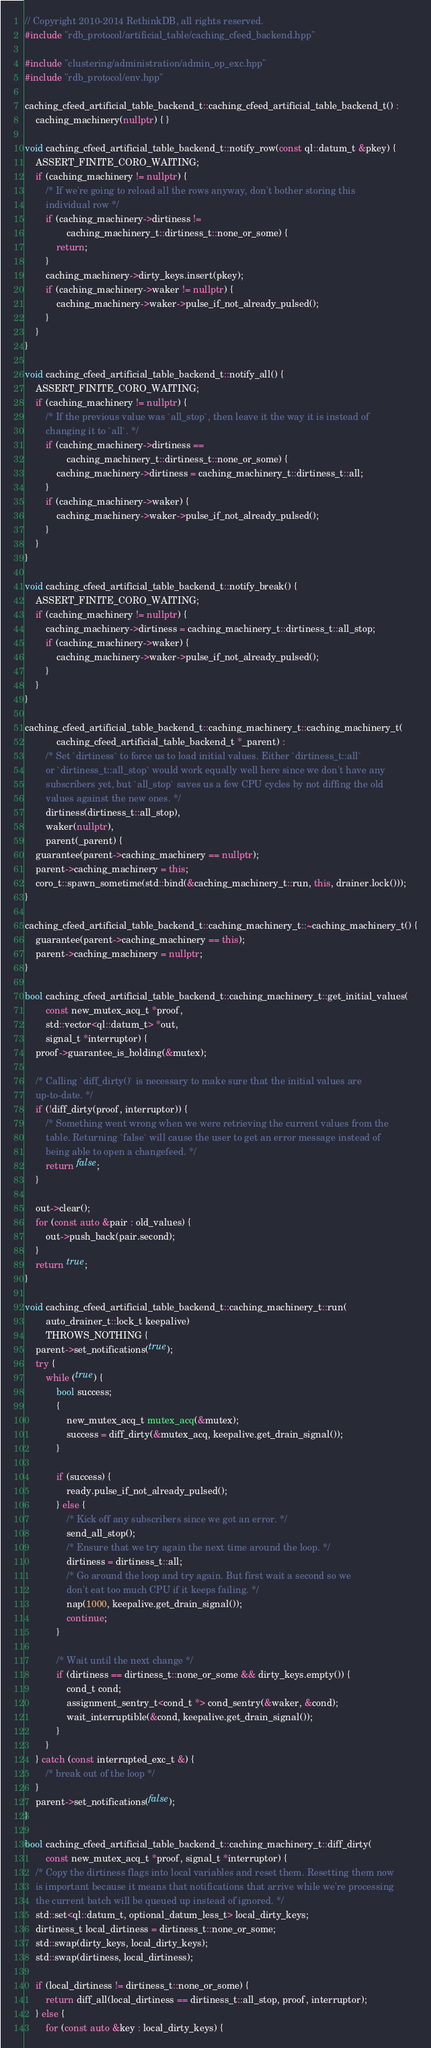<code> <loc_0><loc_0><loc_500><loc_500><_C++_>// Copyright 2010-2014 RethinkDB, all rights reserved.
#include "rdb_protocol/artificial_table/caching_cfeed_backend.hpp"

#include "clustering/administration/admin_op_exc.hpp"
#include "rdb_protocol/env.hpp"

caching_cfeed_artificial_table_backend_t::caching_cfeed_artificial_table_backend_t() :
    caching_machinery(nullptr) { }

void caching_cfeed_artificial_table_backend_t::notify_row(const ql::datum_t &pkey) {
    ASSERT_FINITE_CORO_WAITING;
    if (caching_machinery != nullptr) {
        /* If we're going to reload all the rows anyway, don't bother storing this
        individual row */
        if (caching_machinery->dirtiness !=
                caching_machinery_t::dirtiness_t::none_or_some) {
            return;
        }
        caching_machinery->dirty_keys.insert(pkey);
        if (caching_machinery->waker != nullptr) {
            caching_machinery->waker->pulse_if_not_already_pulsed();
        }
    }
}

void caching_cfeed_artificial_table_backend_t::notify_all() {
    ASSERT_FINITE_CORO_WAITING;
    if (caching_machinery != nullptr) {
        /* If the previous value was `all_stop`, then leave it the way it is instead of
        changing it to `all`. */
        if (caching_machinery->dirtiness ==
                caching_machinery_t::dirtiness_t::none_or_some) {
            caching_machinery->dirtiness = caching_machinery_t::dirtiness_t::all;
        }
        if (caching_machinery->waker) {
            caching_machinery->waker->pulse_if_not_already_pulsed();
        }
    }
}

void caching_cfeed_artificial_table_backend_t::notify_break() {
    ASSERT_FINITE_CORO_WAITING;
    if (caching_machinery != nullptr) {
        caching_machinery->dirtiness = caching_machinery_t::dirtiness_t::all_stop;
        if (caching_machinery->waker) {
            caching_machinery->waker->pulse_if_not_already_pulsed();
        }
    }
}

caching_cfeed_artificial_table_backend_t::caching_machinery_t::caching_machinery_t(
            caching_cfeed_artificial_table_backend_t *_parent) :
        /* Set `dirtiness` to force us to load initial values. Either `dirtiness_t::all`
        or `dirtiness_t::all_stop` would work equally well here since we don't have any
        subscribers yet, but `all_stop` saves us a few CPU cycles by not diffing the old
        values against the new ones. */
        dirtiness(dirtiness_t::all_stop),
        waker(nullptr),
        parent(_parent) {
    guarantee(parent->caching_machinery == nullptr);
    parent->caching_machinery = this;
    coro_t::spawn_sometime(std::bind(&caching_machinery_t::run, this, drainer.lock()));
}

caching_cfeed_artificial_table_backend_t::caching_machinery_t::~caching_machinery_t() {
    guarantee(parent->caching_machinery == this);
    parent->caching_machinery = nullptr;
}

bool caching_cfeed_artificial_table_backend_t::caching_machinery_t::get_initial_values(
        const new_mutex_acq_t *proof,
        std::vector<ql::datum_t> *out,
        signal_t *interruptor) {
    proof->guarantee_is_holding(&mutex);

    /* Calling `diff_dirty()` is necessary to make sure that the initial values are
    up-to-date. */
    if (!diff_dirty(proof, interruptor)) {
        /* Something went wrong when we were retrieving the current values from the
        table. Returning `false` will cause the user to get an error message instead of
        being able to open a changefeed. */
        return false;
    }

    out->clear();
    for (const auto &pair : old_values) {
        out->push_back(pair.second);
    }
    return true;
}

void caching_cfeed_artificial_table_backend_t::caching_machinery_t::run(
        auto_drainer_t::lock_t keepalive)
        THROWS_NOTHING {
    parent->set_notifications(true);
    try {
        while (true) {
            bool success;
            {
                new_mutex_acq_t mutex_acq(&mutex);
                success = diff_dirty(&mutex_acq, keepalive.get_drain_signal());
            }

            if (success) {
                ready.pulse_if_not_already_pulsed();
            } else {
                /* Kick off any subscribers since we got an error. */
                send_all_stop();
                /* Ensure that we try again the next time around the loop. */
                dirtiness = dirtiness_t::all;
                /* Go around the loop and try again. But first wait a second so we
                don't eat too much CPU if it keeps failing. */
                nap(1000, keepalive.get_drain_signal());
                continue;
            }

            /* Wait until the next change */
            if (dirtiness == dirtiness_t::none_or_some && dirty_keys.empty()) {
                cond_t cond;
                assignment_sentry_t<cond_t *> cond_sentry(&waker, &cond);
                wait_interruptible(&cond, keepalive.get_drain_signal());
            }
        }
    } catch (const interrupted_exc_t &) {
        /* break out of the loop */
    }
    parent->set_notifications(false);
}

bool caching_cfeed_artificial_table_backend_t::caching_machinery_t::diff_dirty(
        const new_mutex_acq_t *proof, signal_t *interruptor) {
    /* Copy the dirtiness flags into local variables and reset them. Resetting them now
    is important because it means that notifications that arrive while we're processing
    the current batch will be queued up instead of ignored. */
    std::set<ql::datum_t, optional_datum_less_t> local_dirty_keys;
    dirtiness_t local_dirtiness = dirtiness_t::none_or_some;
    std::swap(dirty_keys, local_dirty_keys);
    std::swap(dirtiness, local_dirtiness);

    if (local_dirtiness != dirtiness_t::none_or_some) {
        return diff_all(local_dirtiness == dirtiness_t::all_stop, proof, interruptor);
    } else {
        for (const auto &key : local_dirty_keys) {</code> 